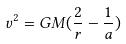Convert formula to latex. <formula><loc_0><loc_0><loc_500><loc_500>v ^ { 2 } = G M ( \frac { 2 } { r } - \frac { 1 } { a } )</formula> 